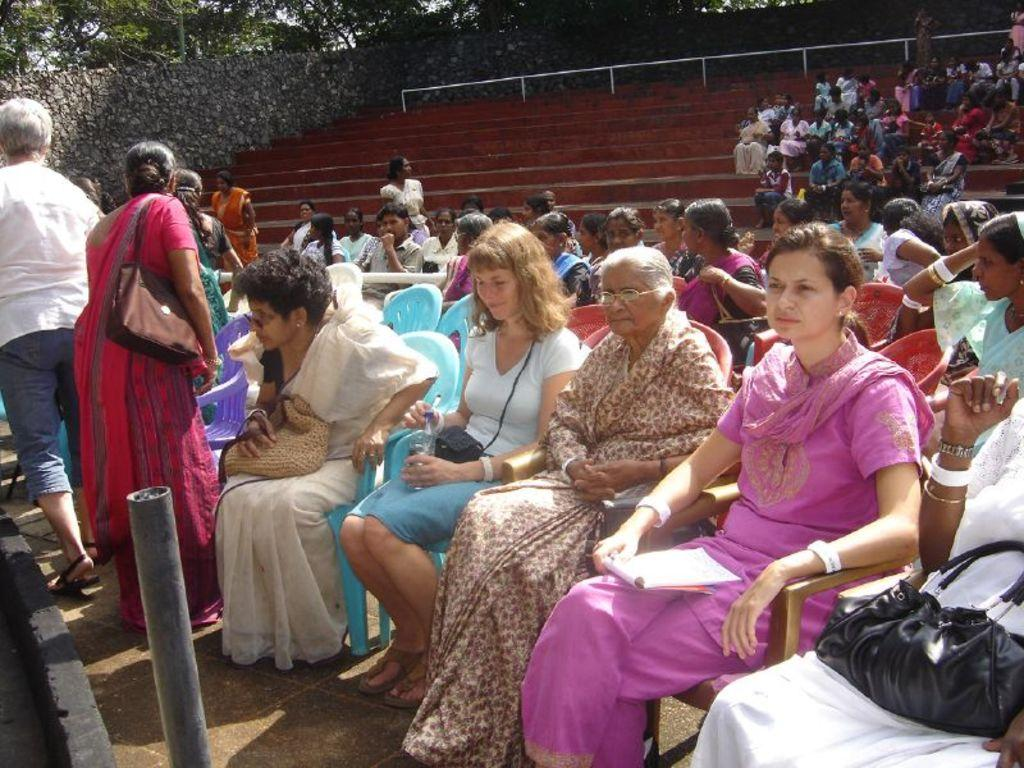What are the people in the image doing? There are many persons sitting on chairs in the image. What can be seen in the background of the image? There is a wall and trees in the background of the image. Can you see any ghosts in the image? There are no ghosts present in the image. What thoughts are the people having in the image? We cannot determine the thoughts of the people in the image based on the provided facts. 